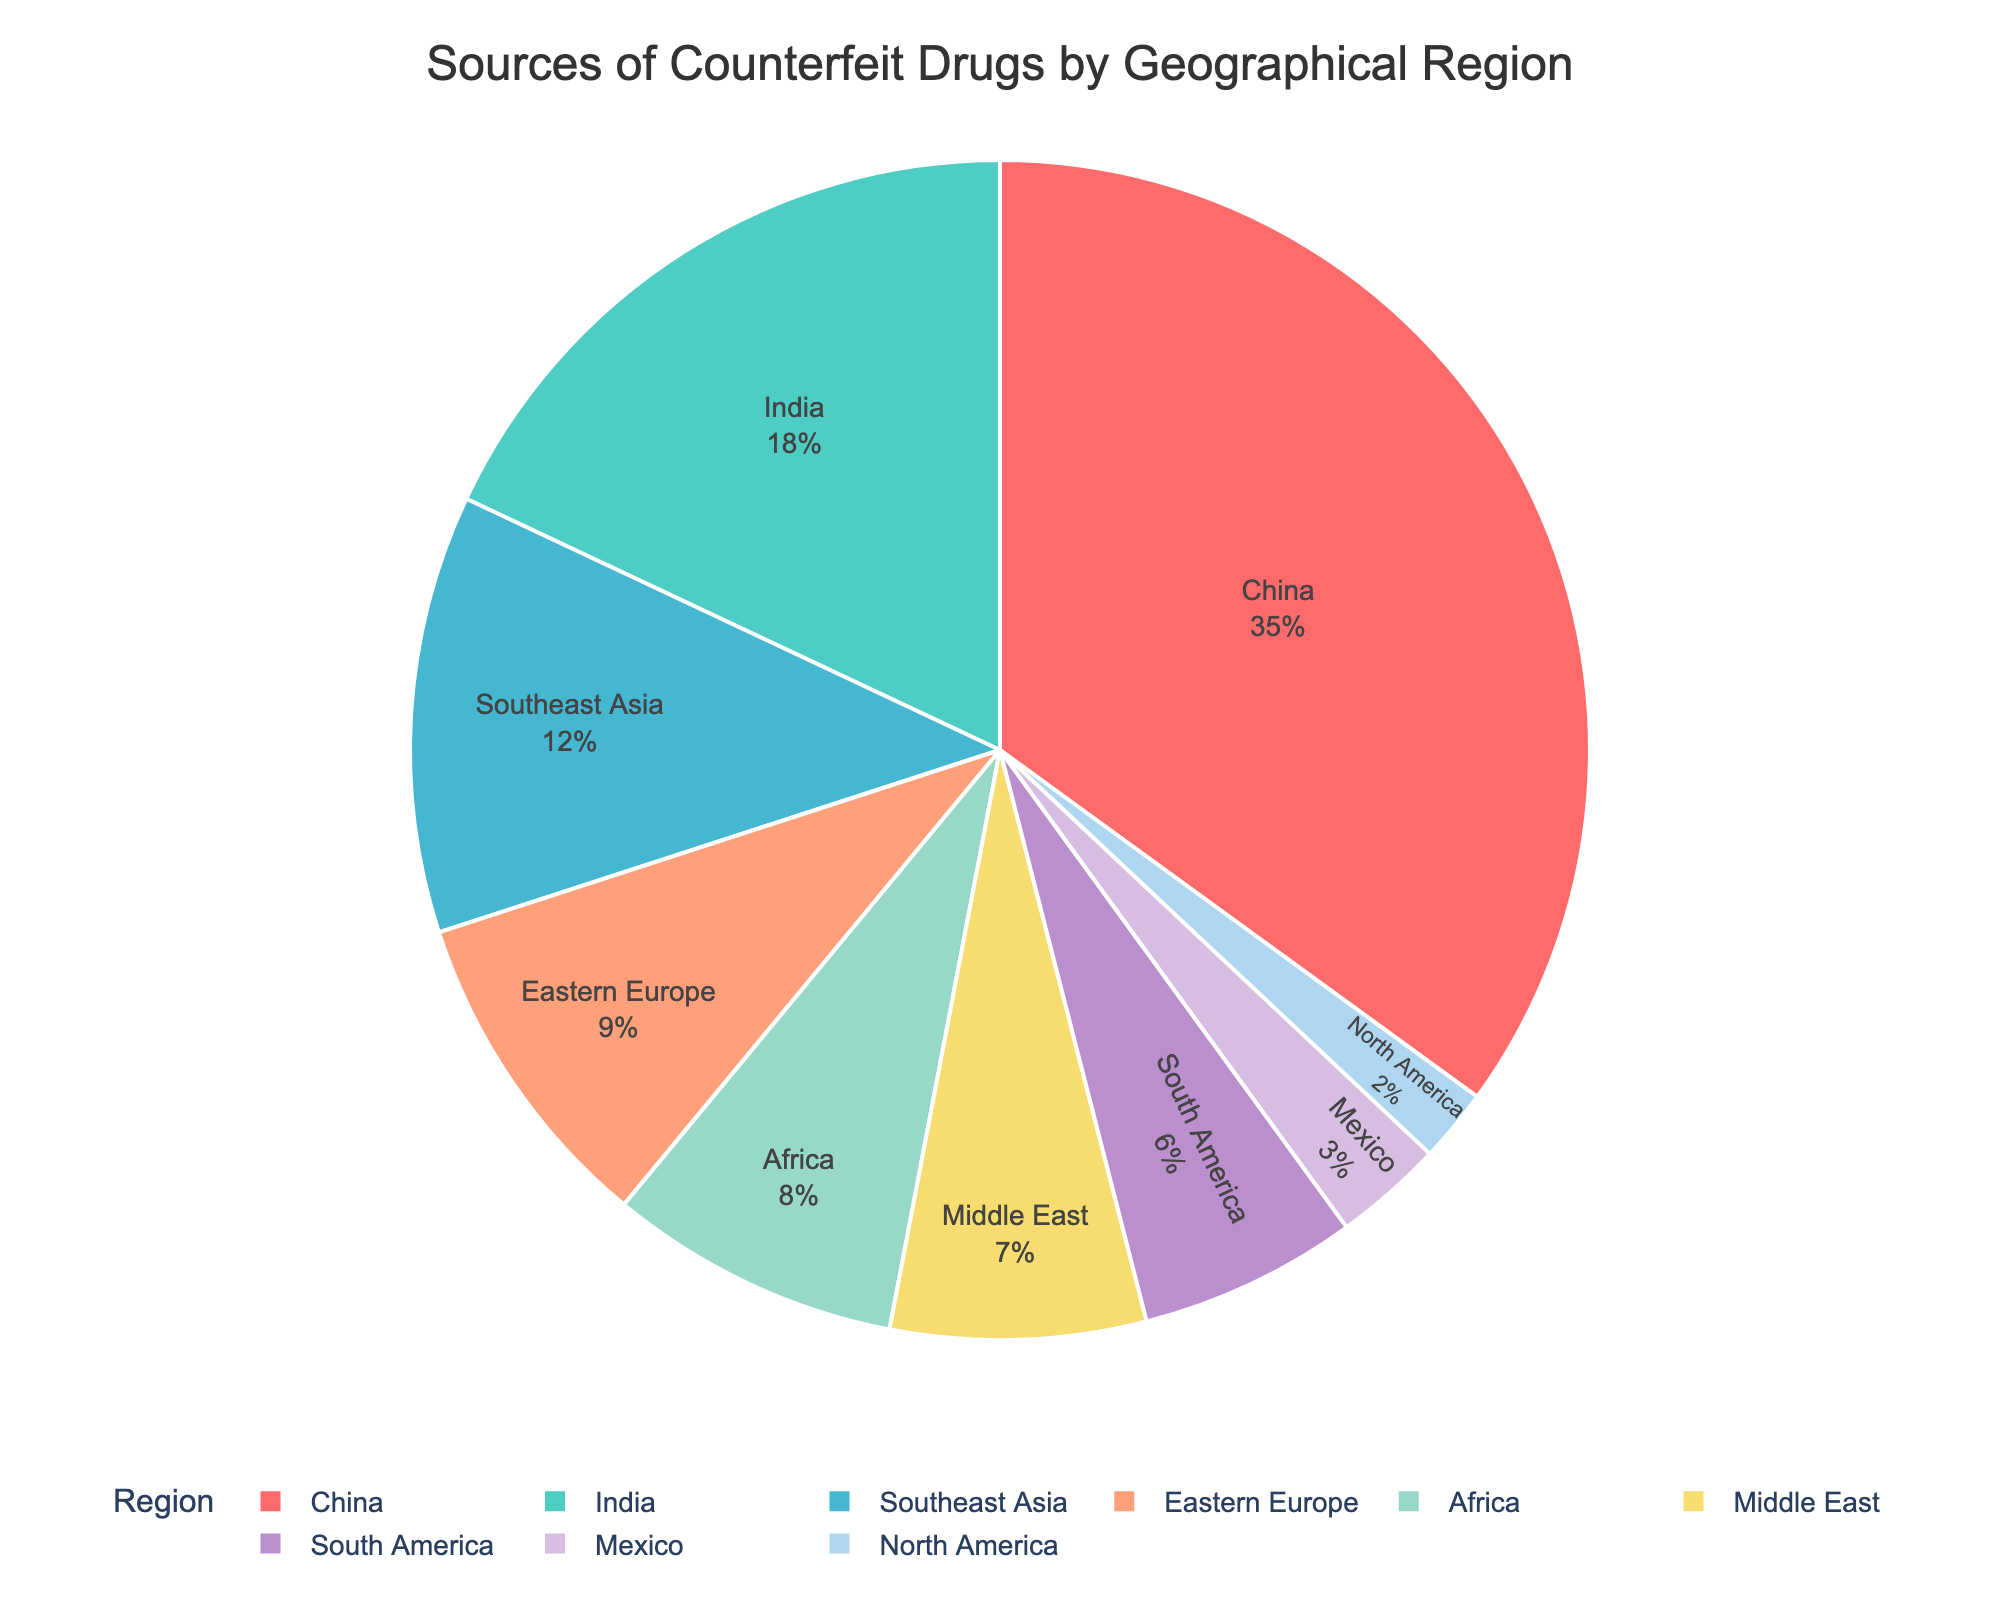What are the top three regions contributing to counterfeit drugs? The figure shows the percentage distribution of counterfeit drugs by region. The top three regions with the highest percentages are China (35%), India (18%), and Southeast Asia (12%).
Answer: China, India, Southeast Asia What is the combined percentage of counterfeit drugs coming from Eastern Europe and Africa? The percentages of counterfeit drugs from Eastern Europe and Africa are 9% and 8%, respectively. Adding these percentages gives us 9% + 8% = 17%.
Answer: 17% Which region contributes less to counterfeit drugs, North America or Mexico? The figure shows the percentage distribution of counterfeit drugs by region. North America contributes 2%, while Mexico contributes 3%. Therefore, North America contributes less.
Answer: North America By how much does the percentage of counterfeit drugs from the Middle East exceed that from South America? The Middle East contributes 7% and South America contributes 6%. The difference is 7% - 6% = 1%.
Answer: 1% Which region is represented by the color red in the pie chart? The pie chart uses a custom color palette. The first color, red, corresponds to the region with the highest percentage, which is China at 35%.
Answer: China How much more counterfeit drugs come from China compared to Southeast Asia? China contributes 35% and Southeast Asia contributes 12%. The difference is 35% - 12% = 23%.
Answer: 23% List all regions contributing less than 10% to counterfeit drugs. The regions contributing less than 10% are Eastern Europe (9%), Africa (8%), Middle East (7%), South America (6%), Mexico (3%), and North America (2%).
Answer: Eastern Europe, Africa, Middle East, South America, Mexico, North America What is the average percentage of counterfeit drugs from the top five regions? The top five regions are China (35%), India (18%), Southeast Asia (12%), Eastern Europe (9%), and Africa (8%). The average is calculated as (35% + 18% + 12% + 9% + 8%) / 5 = 82% / 5 = 16.4%.
Answer: 16.4% Compare the percentages of counterfeit drugs from Southeast Asia and Africa. Which is higher and by how much? The percentages of counterfeit drugs are 12% from Southeast Asia and 8% from Africa. Southeast Asia's contribution is higher by 12% - 8% = 4%.
Answer: Southeast Asia by 4% What is the total percentage of counterfeit drugs from regions outside China? The total percentage of counterfeit drugs from all regions is 100%. Subtracting China's percentage (35%) from 100% gives 100% - 35% = 65%.
Answer: 65% 